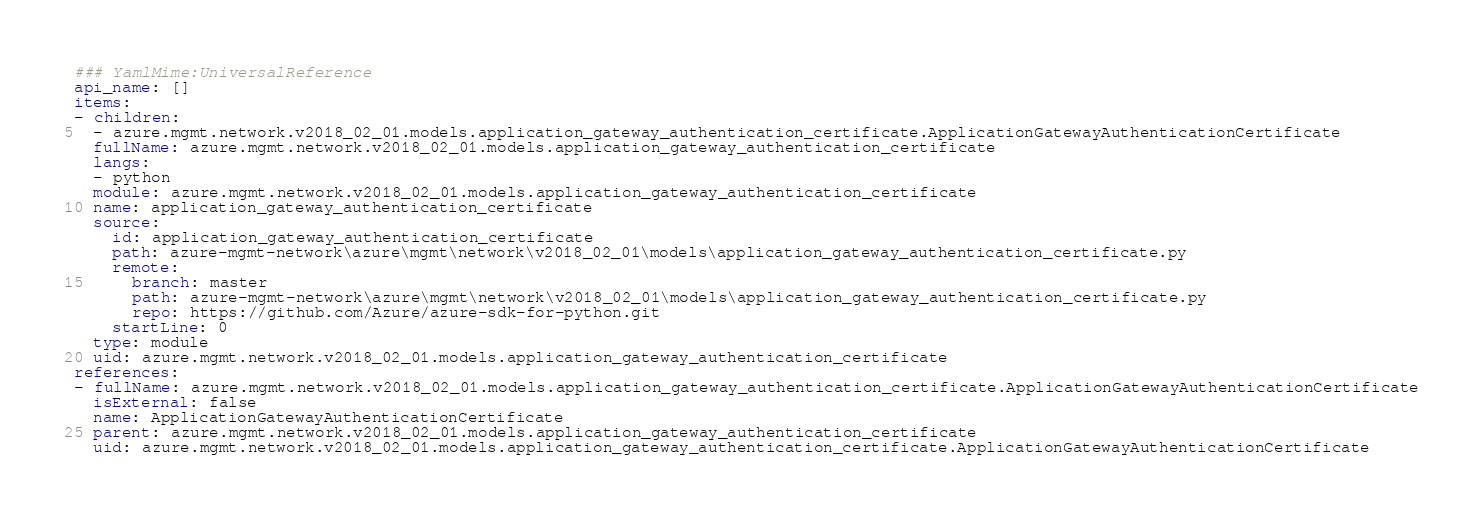Convert code to text. <code><loc_0><loc_0><loc_500><loc_500><_YAML_>### YamlMime:UniversalReference
api_name: []
items:
- children:
  - azure.mgmt.network.v2018_02_01.models.application_gateway_authentication_certificate.ApplicationGatewayAuthenticationCertificate
  fullName: azure.mgmt.network.v2018_02_01.models.application_gateway_authentication_certificate
  langs:
  - python
  module: azure.mgmt.network.v2018_02_01.models.application_gateway_authentication_certificate
  name: application_gateway_authentication_certificate
  source:
    id: application_gateway_authentication_certificate
    path: azure-mgmt-network\azure\mgmt\network\v2018_02_01\models\application_gateway_authentication_certificate.py
    remote:
      branch: master
      path: azure-mgmt-network\azure\mgmt\network\v2018_02_01\models\application_gateway_authentication_certificate.py
      repo: https://github.com/Azure/azure-sdk-for-python.git
    startLine: 0
  type: module
  uid: azure.mgmt.network.v2018_02_01.models.application_gateway_authentication_certificate
references:
- fullName: azure.mgmt.network.v2018_02_01.models.application_gateway_authentication_certificate.ApplicationGatewayAuthenticationCertificate
  isExternal: false
  name: ApplicationGatewayAuthenticationCertificate
  parent: azure.mgmt.network.v2018_02_01.models.application_gateway_authentication_certificate
  uid: azure.mgmt.network.v2018_02_01.models.application_gateway_authentication_certificate.ApplicationGatewayAuthenticationCertificate
</code> 